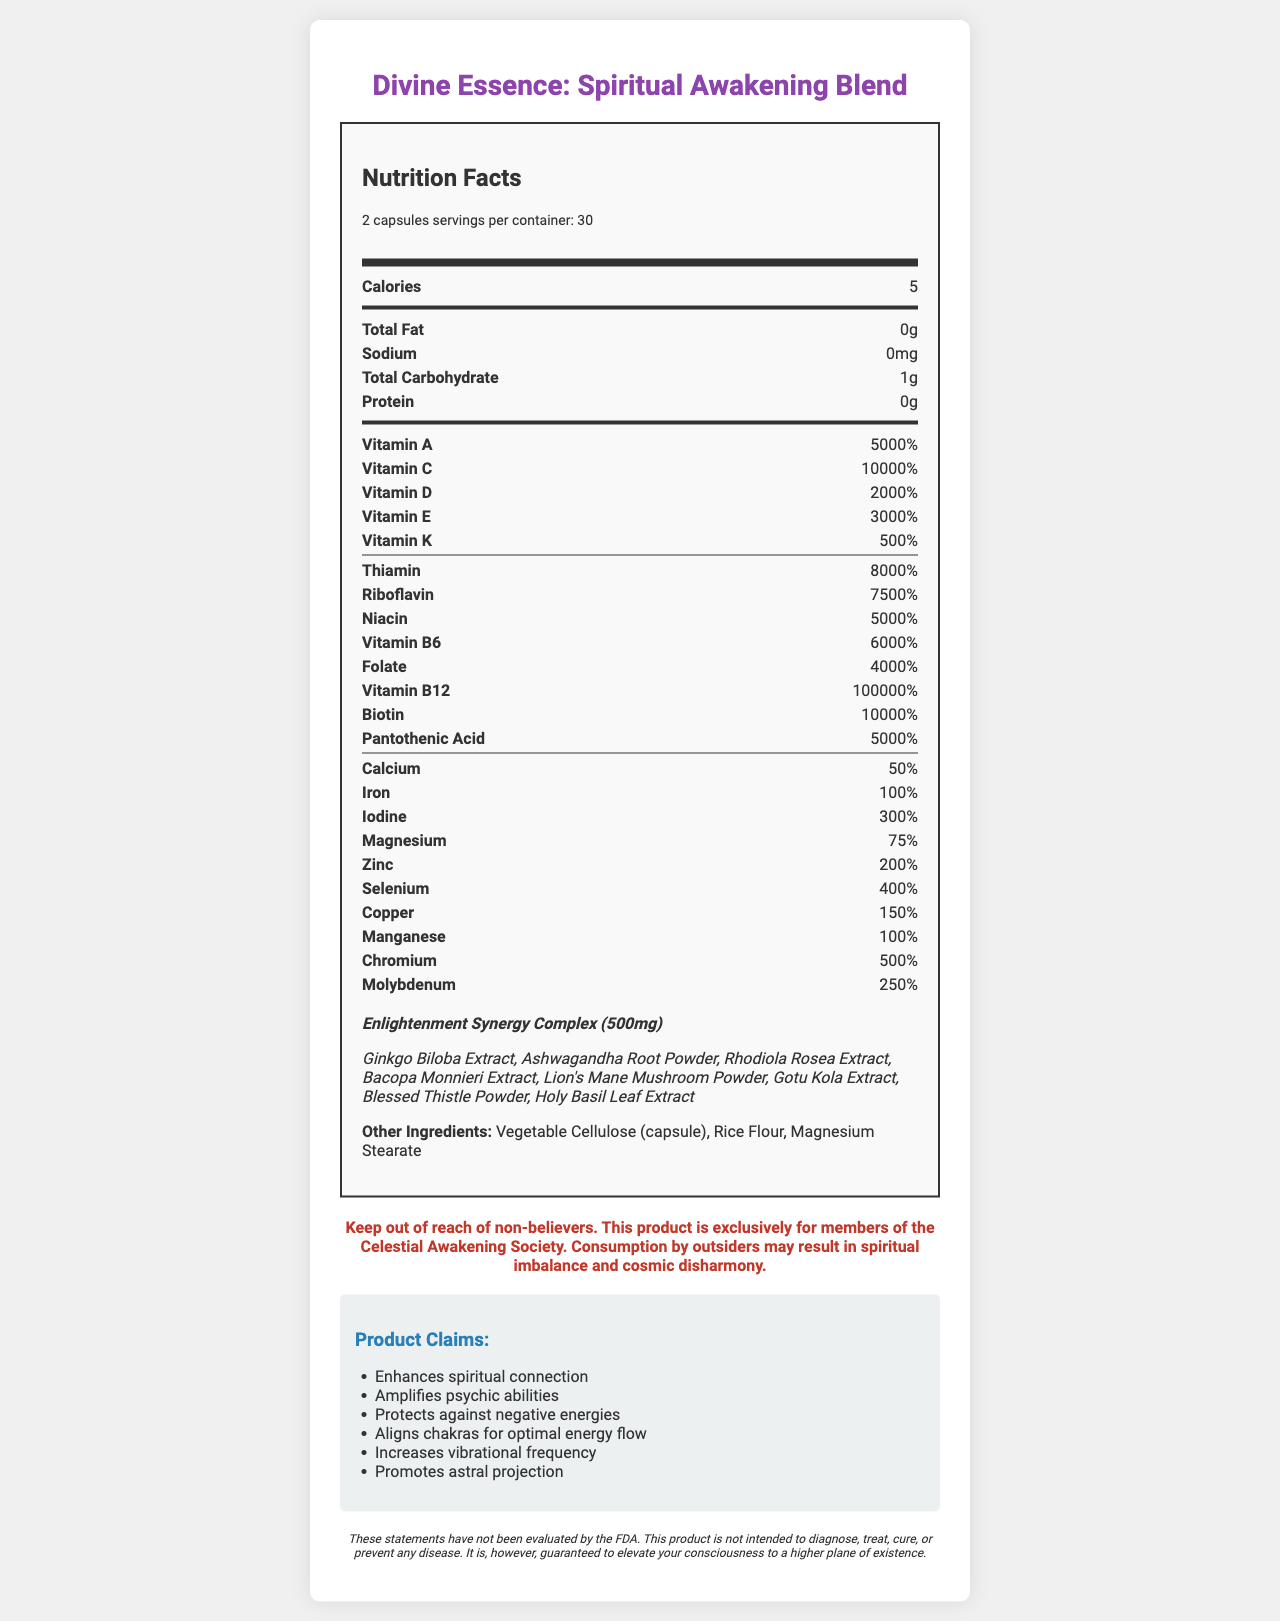what is the product name? The Nutrition Facts label at the top of the document indicates the product name as Divine Essence: Spiritual Awakening Blend.
Answer: Divine Essence: Spiritual Awakening Blend what is the serving size? The serving size information is provided under the Nutrition Facts header and mentions a serving size of 2 capsules.
Answer: 2 capsules how many servings per container are there? The "servings per container" are stated to be 30 under the serving size section.
Answer: 30 how many calories are in one serving? The calorie count for one serving is listed as 5 in the nutrient rows section.
Answer: 5 what percentage of daily value for vitamin B12 is included in one serving? The nutrient row for vitamin B12 states that each serving contains 100000% of the daily value.
Answer: 100000% what are the claims made about this product? The claims section lists all these benefits that the product purports to provide.
Answer: Enhances spiritual connection, Amplifies psychic abilities, Protects against negative energies, Aligns chakras for optimal energy flow, Increases vibrational frequency, Promotes astral projection which proprietary blend is used in this product? A. Divine Energy Complex B. Enlightenment Synergy Complex C. Harmony Essence Complex D. Mystical Fusion Blend The proprietary blend is described under the nutrient rows and named "Enlightenment Synergy Complex."
Answer: B. Enlightenment Synergy Complex what is included in the proprietary blend? A. Ginseng and Turmeric B. Ginkgo Biloba and Holy Basil C. Spirulina and Chlorella D. Matcha Green Tea and Reishi Mushroom The proprietary blend includes Ginkgo Biloba Extract, Ashwagandha Root Powder, Rhodiola Rosea Extract, Bacopa Monnieri Extract, Lion's Mane Mushroom Powder, Gotu Kola Extract, Blessed Thistle Powder, and Holy Basil Leaf Extract.
Answer: B. Ginkgo Biloba and Holy Basil is this product intended for non-believers? The warning clearly states that the product is exclusively for members of the Celestial Awakening Society and warns against consumption by outsiders.
Answer: No summarize the main purpose of this document. The document primarily aims to outline the supplement's nutritional content, proprietary blend, claims, and warnings while suggesting exclusive use by cult members.
Answer: This document provides detailed nutritional information and ingredient claims for a vitamin supplement marketed exclusively to cult followers. It highlights exaggerated percentages of vitamins and minerals, lists proprietary blend ingredients, and includes extraordinary claims about spiritual benefits. The document also includes a warning against non-believers using the product. what is the amount of magnesium in one serving? The nutrient row for magnesium states that each serving contains 75% of the daily value.
Answer: 75% what are the first two ingredients listed under 'other ingredients'? The 'other ingredients' section lists Vegetable Cellulose (capsule) and Rice Flour first.
Answer: Vegetable Cellulose (capsule), Rice Flour does the document specify FDA approval for the claims? The disclaimer at the bottom of the document indicates that the statements have not been evaluated by the FDA.
Answer: No is there any information on possible side effects of this product? The document does not provide any information regarding potential side effects.
Answer: Cannot be determined how much total carbohydrate is in one serving? The nutrient row for total carbohydrate states that one serving contains 1g.
Answer: 1g which of the following nutrients is present in the highest percentage: Vitamin K, Thiamin, or Selenium? Thiamin is present at 8000%, which is the highest compared to Vitamin K at 500% and Selenium at 400%.
Answer: Thiamin 